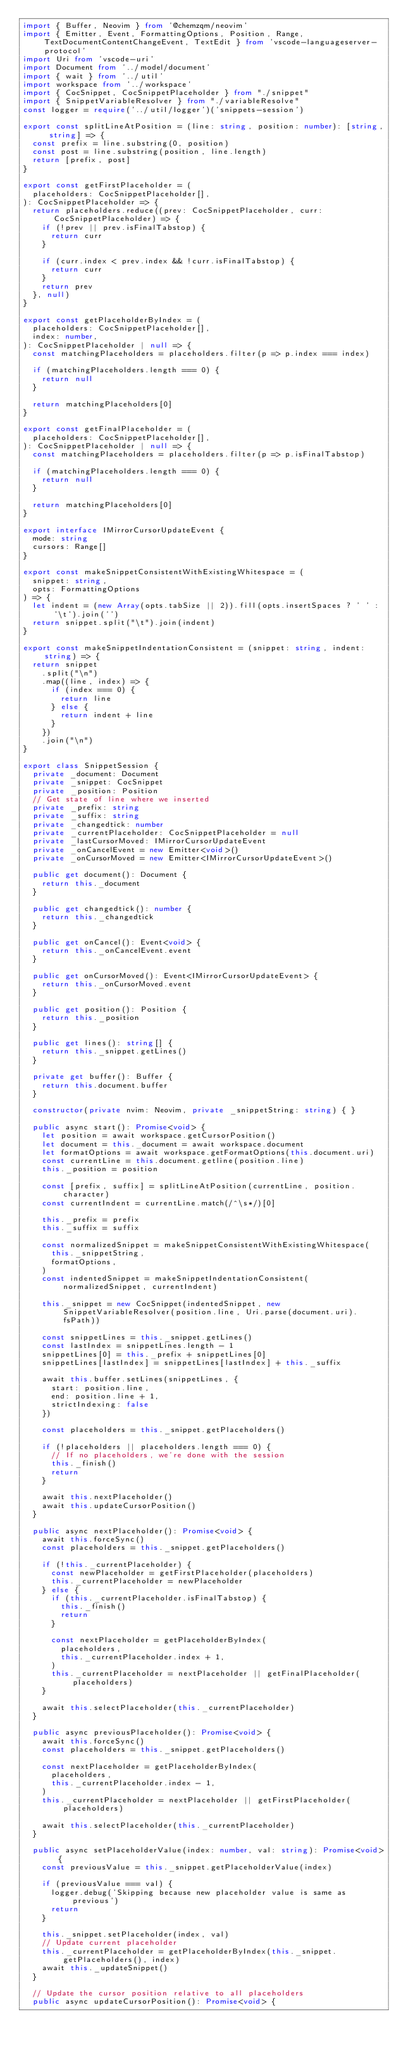<code> <loc_0><loc_0><loc_500><loc_500><_TypeScript_>import { Buffer, Neovim } from '@chemzqm/neovim'
import { Emitter, Event, FormattingOptions, Position, Range, TextDocumentContentChangeEvent, TextEdit } from 'vscode-languageserver-protocol'
import Uri from 'vscode-uri'
import Document from '../model/document'
import { wait } from '../util'
import workspace from '../workspace'
import { CocSnippet, CocSnippetPlaceholder } from "./snippet"
import { SnippetVariableResolver } from "./variableResolve"
const logger = require('../util/logger')('snippets-session')

export const splitLineAtPosition = (line: string, position: number): [string, string] => {
  const prefix = line.substring(0, position)
  const post = line.substring(position, line.length)
  return [prefix, post]
}

export const getFirstPlaceholder = (
  placeholders: CocSnippetPlaceholder[],
): CocSnippetPlaceholder => {
  return placeholders.reduce((prev: CocSnippetPlaceholder, curr: CocSnippetPlaceholder) => {
    if (!prev || prev.isFinalTabstop) {
      return curr
    }

    if (curr.index < prev.index && !curr.isFinalTabstop) {
      return curr
    }
    return prev
  }, null)
}

export const getPlaceholderByIndex = (
  placeholders: CocSnippetPlaceholder[],
  index: number,
): CocSnippetPlaceholder | null => {
  const matchingPlaceholders = placeholders.filter(p => p.index === index)

  if (matchingPlaceholders.length === 0) {
    return null
  }

  return matchingPlaceholders[0]
}

export const getFinalPlaceholder = (
  placeholders: CocSnippetPlaceholder[],
): CocSnippetPlaceholder | null => {
  const matchingPlaceholders = placeholders.filter(p => p.isFinalTabstop)

  if (matchingPlaceholders.length === 0) {
    return null
  }

  return matchingPlaceholders[0]
}

export interface IMirrorCursorUpdateEvent {
  mode: string
  cursors: Range[]
}

export const makeSnippetConsistentWithExistingWhitespace = (
  snippet: string,
  opts: FormattingOptions
) => {
  let indent = (new Array(opts.tabSize || 2)).fill(opts.insertSpaces ? ' ' : '\t').join('')
  return snippet.split("\t").join(indent)
}

export const makeSnippetIndentationConsistent = (snippet: string, indent: string) => {
  return snippet
    .split("\n")
    .map((line, index) => {
      if (index === 0) {
        return line
      } else {
        return indent + line
      }
    })
    .join("\n")
}

export class SnippetSession {
  private _document: Document
  private _snippet: CocSnippet
  private _position: Position
  // Get state of line where we inserted
  private _prefix: string
  private _suffix: string
  private _changedtick: number
  private _currentPlaceholder: CocSnippetPlaceholder = null
  private _lastCursorMoved: IMirrorCursorUpdateEvent
  private _onCancelEvent = new Emitter<void>()
  private _onCursorMoved = new Emitter<IMirrorCursorUpdateEvent>()

  public get document(): Document {
    return this._document
  }

  public get changedtick(): number {
    return this._changedtick
  }

  public get onCancel(): Event<void> {
    return this._onCancelEvent.event
  }

  public get onCursorMoved(): Event<IMirrorCursorUpdateEvent> {
    return this._onCursorMoved.event
  }

  public get position(): Position {
    return this._position
  }

  public get lines(): string[] {
    return this._snippet.getLines()
  }

  private get buffer(): Buffer {
    return this.document.buffer
  }

  constructor(private nvim: Neovim, private _snippetString: string) { }

  public async start(): Promise<void> {
    let position = await workspace.getCursorPosition()
    let document = this._document = await workspace.document
    let formatOptions = await workspace.getFormatOptions(this.document.uri)
    const currentLine = this.document.getline(position.line)
    this._position = position

    const [prefix, suffix] = splitLineAtPosition(currentLine, position.character)
    const currentIndent = currentLine.match(/^\s*/)[0]

    this._prefix = prefix
    this._suffix = suffix

    const normalizedSnippet = makeSnippetConsistentWithExistingWhitespace(
      this._snippetString,
      formatOptions,
    )
    const indentedSnippet = makeSnippetIndentationConsistent(normalizedSnippet, currentIndent)

    this._snippet = new CocSnippet(indentedSnippet, new SnippetVariableResolver(position.line, Uri.parse(document.uri).fsPath))

    const snippetLines = this._snippet.getLines()
    const lastIndex = snippetLines.length - 1
    snippetLines[0] = this._prefix + snippetLines[0]
    snippetLines[lastIndex] = snippetLines[lastIndex] + this._suffix

    await this.buffer.setLines(snippetLines, {
      start: position.line,
      end: position.line + 1,
      strictIndexing: false
    })

    const placeholders = this._snippet.getPlaceholders()

    if (!placeholders || placeholders.length === 0) {
      // If no placeholders, we're done with the session
      this._finish()
      return
    }

    await this.nextPlaceholder()
    await this.updateCursorPosition()
  }

  public async nextPlaceholder(): Promise<void> {
    await this.forceSync()
    const placeholders = this._snippet.getPlaceholders()

    if (!this._currentPlaceholder) {
      const newPlaceholder = getFirstPlaceholder(placeholders)
      this._currentPlaceholder = newPlaceholder
    } else {
      if (this._currentPlaceholder.isFinalTabstop) {
        this._finish()
        return
      }

      const nextPlaceholder = getPlaceholderByIndex(
        placeholders,
        this._currentPlaceholder.index + 1,
      )
      this._currentPlaceholder = nextPlaceholder || getFinalPlaceholder(placeholders)
    }

    await this.selectPlaceholder(this._currentPlaceholder)
  }

  public async previousPlaceholder(): Promise<void> {
    await this.forceSync()
    const placeholders = this._snippet.getPlaceholders()

    const nextPlaceholder = getPlaceholderByIndex(
      placeholders,
      this._currentPlaceholder.index - 1,
    )
    this._currentPlaceholder = nextPlaceholder || getFirstPlaceholder(placeholders)

    await this.selectPlaceholder(this._currentPlaceholder)
  }

  public async setPlaceholderValue(index: number, val: string): Promise<void> {
    const previousValue = this._snippet.getPlaceholderValue(index)

    if (previousValue === val) {
      logger.debug('Skipping because new placeholder value is same as previous')
      return
    }

    this._snippet.setPlaceholder(index, val)
    // Update current placeholder
    this._currentPlaceholder = getPlaceholderByIndex(this._snippet.getPlaceholders(), index)
    await this._updateSnippet()
  }

  // Update the cursor position relative to all placeholders
  public async updateCursorPosition(): Promise<void> {</code> 